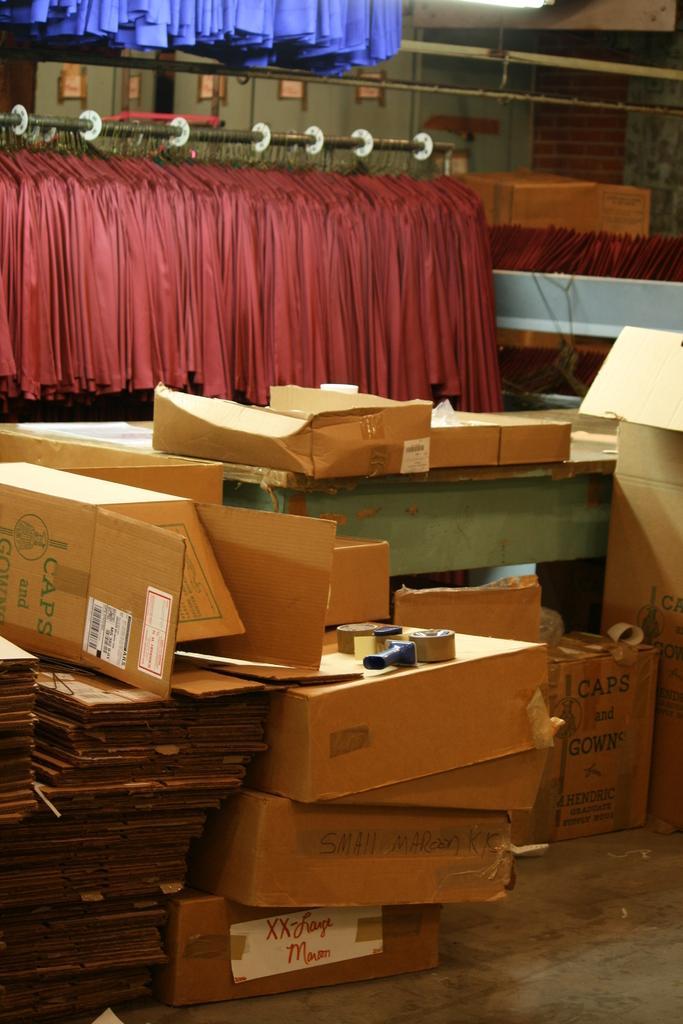Describe this image in one or two sentences. In this image I can see many cardboard box, they are in brown color. Background I can see curtains in maroon and purple color. 